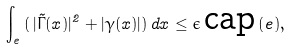Convert formula to latex. <formula><loc_0><loc_0><loc_500><loc_500>\int _ { e } \, ( \, | \vec { \Gamma } ( x ) | ^ { 2 } + | \gamma ( x ) | ) \, d x \leq \epsilon \, \text {cap} \, ( e ) ,</formula> 